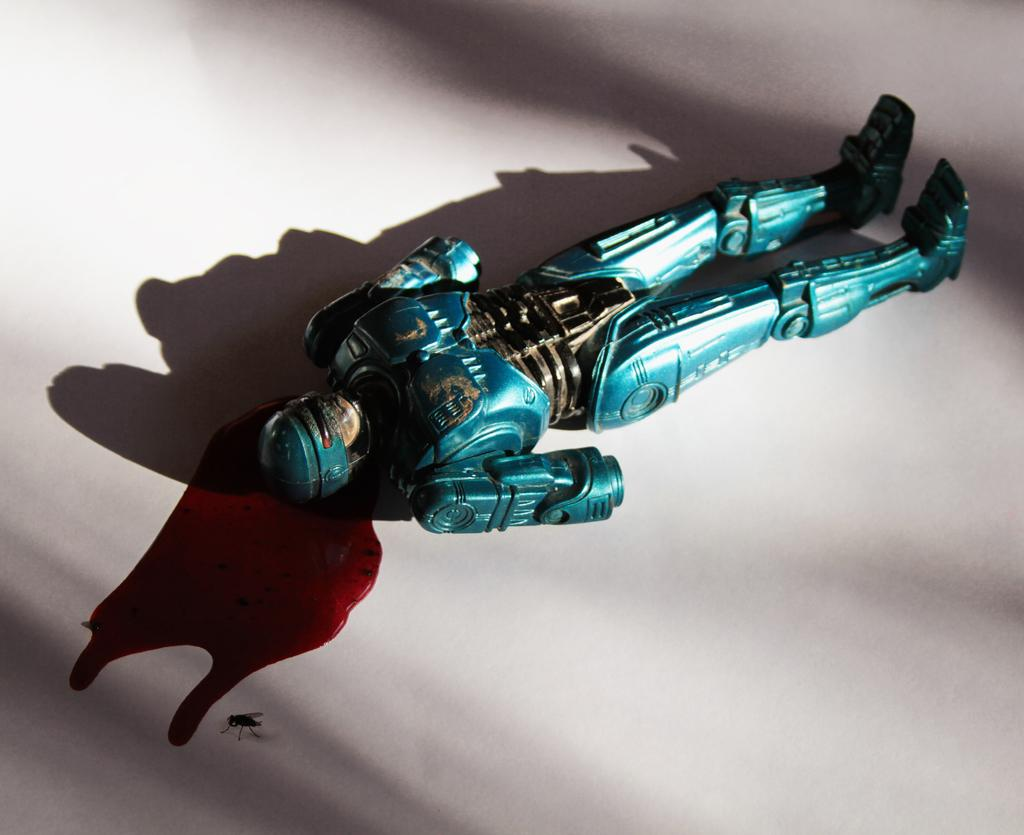What object in the image is likely meant for play or amusement? There is a toy in the image. What substance is present that typically indicates injury or harm? There is blood in the image. What type of insect can be seen in the image? There is a fly in the image. What color is the primary background or surface in the image? The surface is white. How many legs does the lumber have in the image? There is no lumber present in the image, and therefore no legs can be counted. What type of toe is visible on the toy in the image? There is no toy with a toe present in the image. 